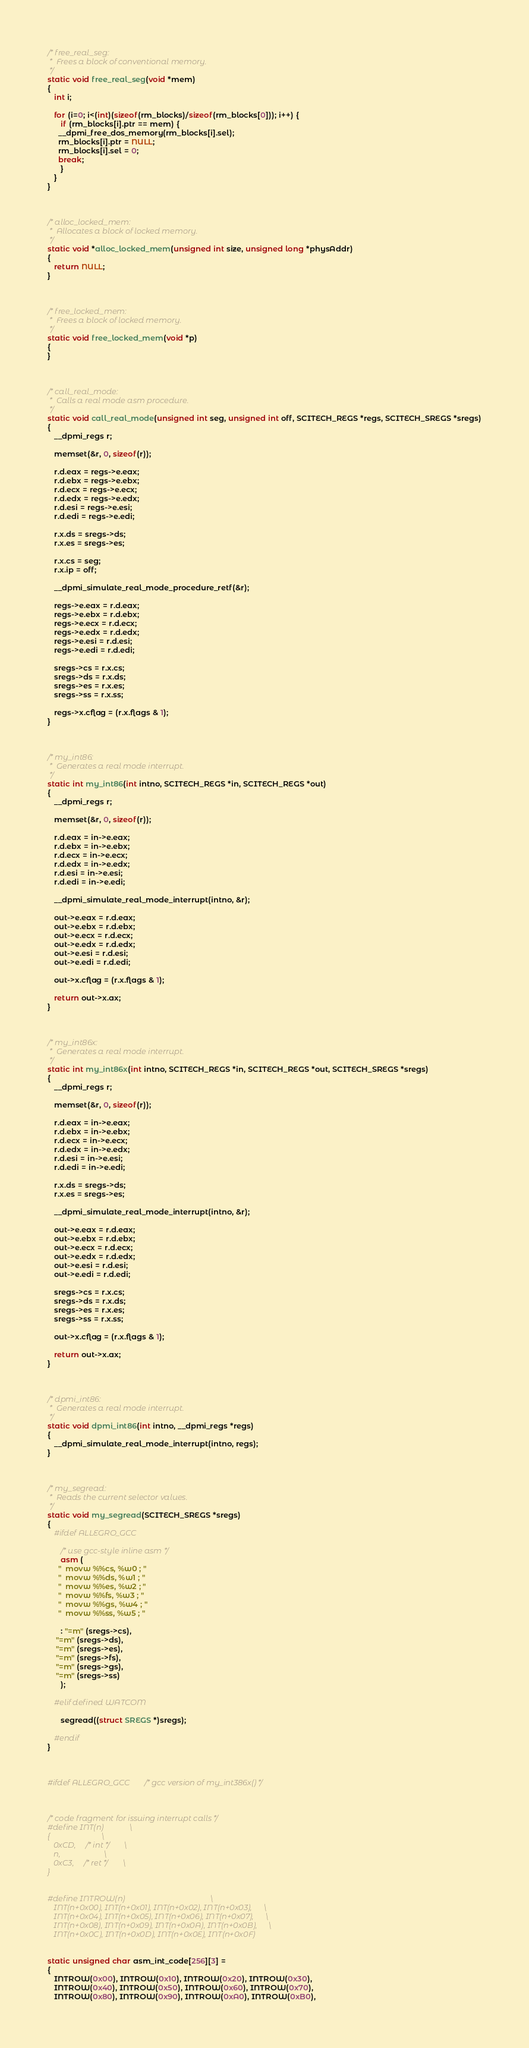Convert code to text. <code><loc_0><loc_0><loc_500><loc_500><_C_>/* free_real_seg:
 *  Frees a block of conventional memory.
 */
static void free_real_seg(void *mem)
{
   int i;

   for (i=0; i<(int)(sizeof(rm_blocks)/sizeof(rm_blocks[0])); i++) {
      if (rm_blocks[i].ptr == mem) {
	 __dpmi_free_dos_memory(rm_blocks[i].sel);
	 rm_blocks[i].ptr = NULL;
	 rm_blocks[i].sel = 0;
	 break;
      }
   }
}



/* alloc_locked_mem:
 *  Allocates a block of locked memory.
 */
static void *alloc_locked_mem(unsigned int size, unsigned long *physAddr)
{
   return NULL;
}



/* free_locked_mem:
 *  Frees a block of locked memory.
 */
static void free_locked_mem(void *p)
{
}



/* call_real_mode:
 *  Calls a real mode asm procedure.
 */
static void call_real_mode(unsigned int seg, unsigned int off, SCITECH_REGS *regs, SCITECH_SREGS *sregs)
{
   __dpmi_regs r;

   memset(&r, 0, sizeof(r));

   r.d.eax = regs->e.eax;
   r.d.ebx = regs->e.ebx;
   r.d.ecx = regs->e.ecx;
   r.d.edx = regs->e.edx;
   r.d.esi = regs->e.esi;
   r.d.edi = regs->e.edi;

   r.x.ds = sregs->ds;
   r.x.es = sregs->es;

   r.x.cs = seg;
   r.x.ip = off;

   __dpmi_simulate_real_mode_procedure_retf(&r);

   regs->e.eax = r.d.eax;
   regs->e.ebx = r.d.ebx;
   regs->e.ecx = r.d.ecx;
   regs->e.edx = r.d.edx;
   regs->e.esi = r.d.esi;
   regs->e.edi = r.d.edi;

   sregs->cs = r.x.cs;
   sregs->ds = r.x.ds;
   sregs->es = r.x.es;
   sregs->ss = r.x.ss;

   regs->x.cflag = (r.x.flags & 1);
}



/* my_int86:
 *  Generates a real mode interrupt.
 */
static int my_int86(int intno, SCITECH_REGS *in, SCITECH_REGS *out)
{
   __dpmi_regs r;

   memset(&r, 0, sizeof(r));

   r.d.eax = in->e.eax;
   r.d.ebx = in->e.ebx;
   r.d.ecx = in->e.ecx;
   r.d.edx = in->e.edx;
   r.d.esi = in->e.esi;
   r.d.edi = in->e.edi;

   __dpmi_simulate_real_mode_interrupt(intno, &r);

   out->e.eax = r.d.eax;
   out->e.ebx = r.d.ebx;
   out->e.ecx = r.d.ecx;
   out->e.edx = r.d.edx;
   out->e.esi = r.d.esi;
   out->e.edi = r.d.edi;

   out->x.cflag = (r.x.flags & 1);

   return out->x.ax;
}



/* my_int86x:
 *  Generates a real mode interrupt.
 */
static int my_int86x(int intno, SCITECH_REGS *in, SCITECH_REGS *out, SCITECH_SREGS *sregs)
{
   __dpmi_regs r;

   memset(&r, 0, sizeof(r));

   r.d.eax = in->e.eax;
   r.d.ebx = in->e.ebx;
   r.d.ecx = in->e.ecx;
   r.d.edx = in->e.edx;
   r.d.esi = in->e.esi;
   r.d.edi = in->e.edi;

   r.x.ds = sregs->ds;
   r.x.es = sregs->es;

   __dpmi_simulate_real_mode_interrupt(intno, &r);

   out->e.eax = r.d.eax;
   out->e.ebx = r.d.ebx;
   out->e.ecx = r.d.ecx;
   out->e.edx = r.d.edx;
   out->e.esi = r.d.esi;
   out->e.edi = r.d.edi;

   sregs->cs = r.x.cs;
   sregs->ds = r.x.ds;
   sregs->es = r.x.es;
   sregs->ss = r.x.ss;

   out->x.cflag = (r.x.flags & 1);

   return out->x.ax;
}



/* dpmi_int86:
 *  Generates a real mode interrupt.
 */
static void dpmi_int86(int intno, __dpmi_regs *regs)
{
   __dpmi_simulate_real_mode_interrupt(intno, regs);
}



/* my_segread:
 *  Reads the current selector values.
 */
static void my_segread(SCITECH_SREGS *sregs)
{
   #ifdef ALLEGRO_GCC

      /* use gcc-style inline asm */
      asm (
	 "  movw %%cs, %w0 ; "
	 "  movw %%ds, %w1 ; "
	 "  movw %%es, %w2 ; "
	 "  movw %%fs, %w3 ; "
	 "  movw %%gs, %w4 ; "
	 "  movw %%ss, %w5 ; "

      : "=m" (sregs->cs),
	"=m" (sregs->ds),
	"=m" (sregs->es),
	"=m" (sregs->fs),
	"=m" (sregs->gs),
	"=m" (sregs->ss)
      );

   #elif defined WATCOM

      segread((struct SREGS *)sregs);

   #endif
}



#ifdef ALLEGRO_GCC      /* gcc version of my_int386x() */



/* code fragment for issuing interrupt calls */
#define INT(n)             \
{                          \
   0xCD,    /* int */      \
   n,                      \
   0xC3,    /* ret */      \
}


#define INTROW(n)                                           \
   INT(n+0x00), INT(n+0x01), INT(n+0x02), INT(n+0x03),      \
   INT(n+0x04), INT(n+0x05), INT(n+0x06), INT(n+0x07),      \
   INT(n+0x08), INT(n+0x09), INT(n+0x0A), INT(n+0x0B),      \
   INT(n+0x0C), INT(n+0x0D), INT(n+0x0E), INT(n+0x0F)


static unsigned char asm_int_code[256][3] = 
{ 
   INTROW(0x00), INTROW(0x10), INTROW(0x20), INTROW(0x30),
   INTROW(0x40), INTROW(0x50), INTROW(0x60), INTROW(0x70),
   INTROW(0x80), INTROW(0x90), INTROW(0xA0), INTROW(0xB0),</code> 